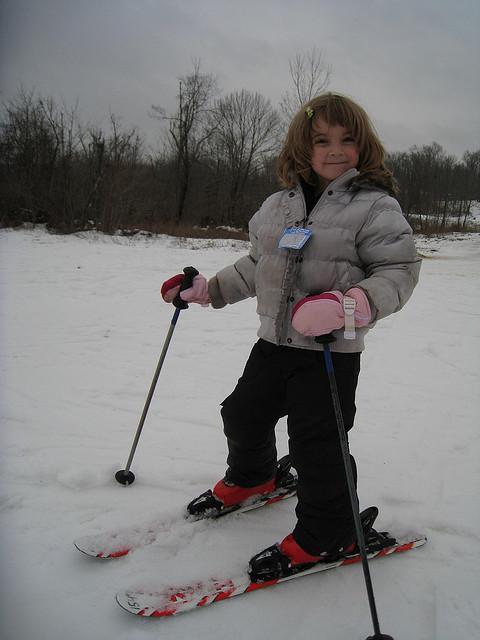How many decks does this bus have?
Give a very brief answer. 0. 